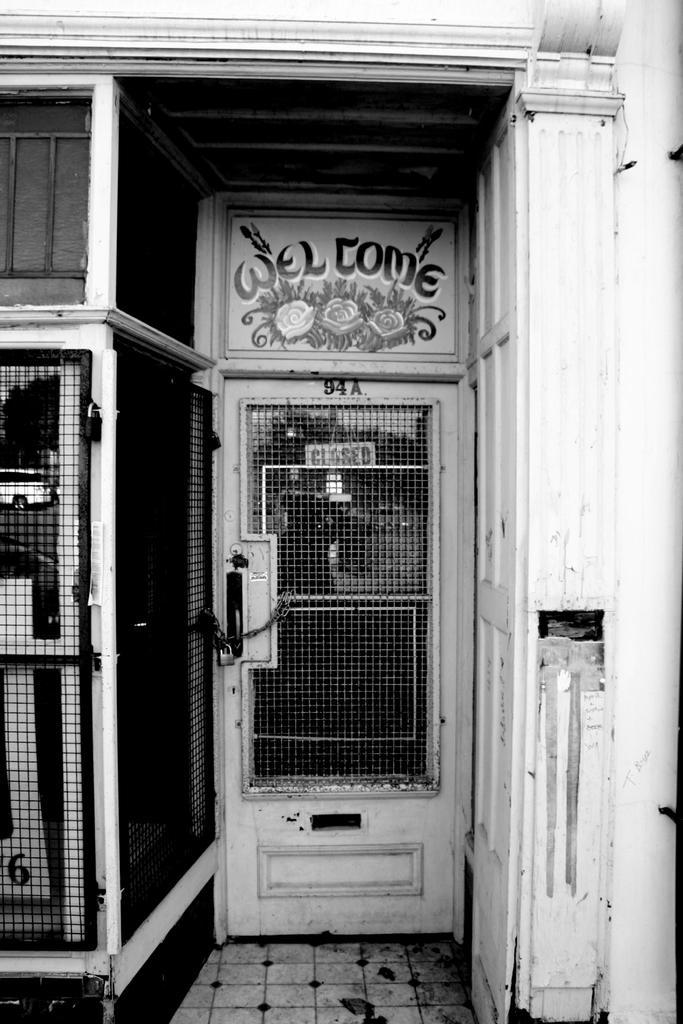Please provide a concise description of this image. This is a black and white image. In this image we can see a door of a building with some text on it, a board, a grill and a lock to it. 